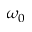<formula> <loc_0><loc_0><loc_500><loc_500>\omega _ { 0 }</formula> 